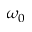<formula> <loc_0><loc_0><loc_500><loc_500>\omega _ { 0 }</formula> 